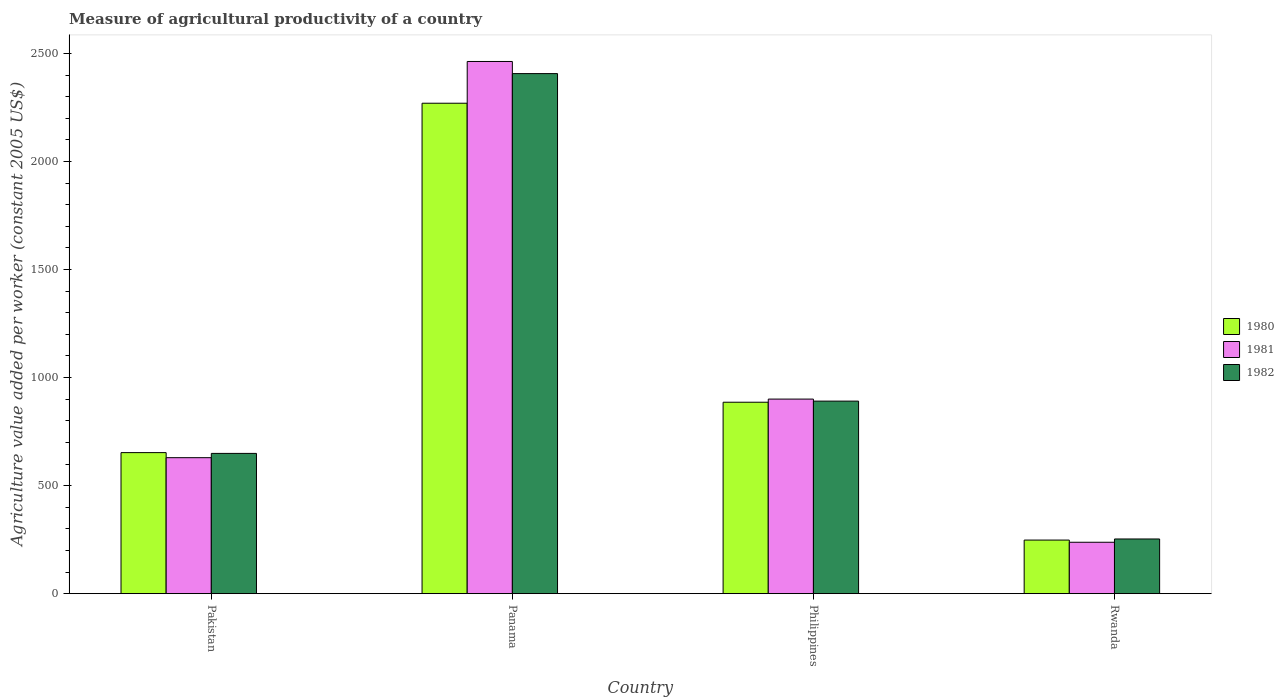How many bars are there on the 2nd tick from the left?
Provide a succinct answer. 3. What is the label of the 4th group of bars from the left?
Give a very brief answer. Rwanda. What is the measure of agricultural productivity in 1980 in Philippines?
Your response must be concise. 885.98. Across all countries, what is the maximum measure of agricultural productivity in 1982?
Provide a succinct answer. 2406.98. Across all countries, what is the minimum measure of agricultural productivity in 1981?
Your answer should be compact. 237.92. In which country was the measure of agricultural productivity in 1981 maximum?
Give a very brief answer. Panama. In which country was the measure of agricultural productivity in 1980 minimum?
Give a very brief answer. Rwanda. What is the total measure of agricultural productivity in 1981 in the graph?
Ensure brevity in your answer.  4230.88. What is the difference between the measure of agricultural productivity in 1980 in Panama and that in Philippines?
Offer a very short reply. 1383.91. What is the difference between the measure of agricultural productivity in 1981 in Panama and the measure of agricultural productivity in 1982 in Pakistan?
Your response must be concise. 1813.88. What is the average measure of agricultural productivity in 1981 per country?
Provide a short and direct response. 1057.72. What is the difference between the measure of agricultural productivity of/in 1980 and measure of agricultural productivity of/in 1982 in Pakistan?
Your answer should be compact. 3.62. What is the ratio of the measure of agricultural productivity in 1980 in Philippines to that in Rwanda?
Offer a very short reply. 3.57. What is the difference between the highest and the second highest measure of agricultural productivity in 1982?
Your answer should be very brief. -241.93. What is the difference between the highest and the lowest measure of agricultural productivity in 1980?
Keep it short and to the point. 2021.89. In how many countries, is the measure of agricultural productivity in 1980 greater than the average measure of agricultural productivity in 1980 taken over all countries?
Keep it short and to the point. 1. Is the sum of the measure of agricultural productivity in 1980 in Pakistan and Philippines greater than the maximum measure of agricultural productivity in 1981 across all countries?
Provide a succinct answer. No. How many bars are there?
Offer a very short reply. 12. Are all the bars in the graph horizontal?
Offer a terse response. No. Are the values on the major ticks of Y-axis written in scientific E-notation?
Your answer should be compact. No. Does the graph contain any zero values?
Offer a very short reply. No. How are the legend labels stacked?
Your response must be concise. Vertical. What is the title of the graph?
Ensure brevity in your answer.  Measure of agricultural productivity of a country. Does "1975" appear as one of the legend labels in the graph?
Your response must be concise. No. What is the label or title of the Y-axis?
Make the answer very short. Agriculture value added per worker (constant 2005 US$). What is the Agriculture value added per worker (constant 2005 US$) of 1980 in Pakistan?
Offer a terse response. 652.79. What is the Agriculture value added per worker (constant 2005 US$) in 1981 in Pakistan?
Ensure brevity in your answer.  629.36. What is the Agriculture value added per worker (constant 2005 US$) in 1982 in Pakistan?
Ensure brevity in your answer.  649.18. What is the Agriculture value added per worker (constant 2005 US$) of 1980 in Panama?
Keep it short and to the point. 2269.89. What is the Agriculture value added per worker (constant 2005 US$) of 1981 in Panama?
Your answer should be very brief. 2463.06. What is the Agriculture value added per worker (constant 2005 US$) of 1982 in Panama?
Keep it short and to the point. 2406.98. What is the Agriculture value added per worker (constant 2005 US$) of 1980 in Philippines?
Your answer should be very brief. 885.98. What is the Agriculture value added per worker (constant 2005 US$) of 1981 in Philippines?
Ensure brevity in your answer.  900.55. What is the Agriculture value added per worker (constant 2005 US$) in 1982 in Philippines?
Your answer should be compact. 891.1. What is the Agriculture value added per worker (constant 2005 US$) in 1980 in Rwanda?
Provide a succinct answer. 248.01. What is the Agriculture value added per worker (constant 2005 US$) of 1981 in Rwanda?
Your answer should be very brief. 237.92. What is the Agriculture value added per worker (constant 2005 US$) in 1982 in Rwanda?
Ensure brevity in your answer.  253.09. Across all countries, what is the maximum Agriculture value added per worker (constant 2005 US$) in 1980?
Ensure brevity in your answer.  2269.89. Across all countries, what is the maximum Agriculture value added per worker (constant 2005 US$) in 1981?
Make the answer very short. 2463.06. Across all countries, what is the maximum Agriculture value added per worker (constant 2005 US$) of 1982?
Offer a very short reply. 2406.98. Across all countries, what is the minimum Agriculture value added per worker (constant 2005 US$) in 1980?
Offer a very short reply. 248.01. Across all countries, what is the minimum Agriculture value added per worker (constant 2005 US$) of 1981?
Keep it short and to the point. 237.92. Across all countries, what is the minimum Agriculture value added per worker (constant 2005 US$) of 1982?
Your response must be concise. 253.09. What is the total Agriculture value added per worker (constant 2005 US$) of 1980 in the graph?
Give a very brief answer. 4056.67. What is the total Agriculture value added per worker (constant 2005 US$) of 1981 in the graph?
Your response must be concise. 4230.88. What is the total Agriculture value added per worker (constant 2005 US$) in 1982 in the graph?
Your response must be concise. 4200.35. What is the difference between the Agriculture value added per worker (constant 2005 US$) of 1980 in Pakistan and that in Panama?
Make the answer very short. -1617.1. What is the difference between the Agriculture value added per worker (constant 2005 US$) of 1981 in Pakistan and that in Panama?
Offer a terse response. -1833.7. What is the difference between the Agriculture value added per worker (constant 2005 US$) in 1982 in Pakistan and that in Panama?
Make the answer very short. -1757.8. What is the difference between the Agriculture value added per worker (constant 2005 US$) in 1980 in Pakistan and that in Philippines?
Offer a terse response. -233.19. What is the difference between the Agriculture value added per worker (constant 2005 US$) of 1981 in Pakistan and that in Philippines?
Provide a short and direct response. -271.19. What is the difference between the Agriculture value added per worker (constant 2005 US$) of 1982 in Pakistan and that in Philippines?
Your answer should be compact. -241.93. What is the difference between the Agriculture value added per worker (constant 2005 US$) of 1980 in Pakistan and that in Rwanda?
Offer a very short reply. 404.79. What is the difference between the Agriculture value added per worker (constant 2005 US$) of 1981 in Pakistan and that in Rwanda?
Your answer should be very brief. 391.44. What is the difference between the Agriculture value added per worker (constant 2005 US$) of 1982 in Pakistan and that in Rwanda?
Provide a succinct answer. 396.09. What is the difference between the Agriculture value added per worker (constant 2005 US$) in 1980 in Panama and that in Philippines?
Provide a short and direct response. 1383.91. What is the difference between the Agriculture value added per worker (constant 2005 US$) of 1981 in Panama and that in Philippines?
Ensure brevity in your answer.  1562.51. What is the difference between the Agriculture value added per worker (constant 2005 US$) in 1982 in Panama and that in Philippines?
Your response must be concise. 1515.88. What is the difference between the Agriculture value added per worker (constant 2005 US$) of 1980 in Panama and that in Rwanda?
Provide a succinct answer. 2021.89. What is the difference between the Agriculture value added per worker (constant 2005 US$) in 1981 in Panama and that in Rwanda?
Offer a very short reply. 2225.14. What is the difference between the Agriculture value added per worker (constant 2005 US$) of 1982 in Panama and that in Rwanda?
Provide a short and direct response. 2153.89. What is the difference between the Agriculture value added per worker (constant 2005 US$) of 1980 in Philippines and that in Rwanda?
Give a very brief answer. 637.98. What is the difference between the Agriculture value added per worker (constant 2005 US$) in 1981 in Philippines and that in Rwanda?
Make the answer very short. 662.63. What is the difference between the Agriculture value added per worker (constant 2005 US$) in 1982 in Philippines and that in Rwanda?
Provide a short and direct response. 638.01. What is the difference between the Agriculture value added per worker (constant 2005 US$) in 1980 in Pakistan and the Agriculture value added per worker (constant 2005 US$) in 1981 in Panama?
Give a very brief answer. -1810.26. What is the difference between the Agriculture value added per worker (constant 2005 US$) of 1980 in Pakistan and the Agriculture value added per worker (constant 2005 US$) of 1982 in Panama?
Offer a very short reply. -1754.19. What is the difference between the Agriculture value added per worker (constant 2005 US$) in 1981 in Pakistan and the Agriculture value added per worker (constant 2005 US$) in 1982 in Panama?
Ensure brevity in your answer.  -1777.62. What is the difference between the Agriculture value added per worker (constant 2005 US$) in 1980 in Pakistan and the Agriculture value added per worker (constant 2005 US$) in 1981 in Philippines?
Keep it short and to the point. -247.75. What is the difference between the Agriculture value added per worker (constant 2005 US$) of 1980 in Pakistan and the Agriculture value added per worker (constant 2005 US$) of 1982 in Philippines?
Your response must be concise. -238.31. What is the difference between the Agriculture value added per worker (constant 2005 US$) in 1981 in Pakistan and the Agriculture value added per worker (constant 2005 US$) in 1982 in Philippines?
Offer a terse response. -261.75. What is the difference between the Agriculture value added per worker (constant 2005 US$) of 1980 in Pakistan and the Agriculture value added per worker (constant 2005 US$) of 1981 in Rwanda?
Offer a very short reply. 414.88. What is the difference between the Agriculture value added per worker (constant 2005 US$) of 1980 in Pakistan and the Agriculture value added per worker (constant 2005 US$) of 1982 in Rwanda?
Provide a succinct answer. 399.7. What is the difference between the Agriculture value added per worker (constant 2005 US$) in 1981 in Pakistan and the Agriculture value added per worker (constant 2005 US$) in 1982 in Rwanda?
Make the answer very short. 376.27. What is the difference between the Agriculture value added per worker (constant 2005 US$) of 1980 in Panama and the Agriculture value added per worker (constant 2005 US$) of 1981 in Philippines?
Make the answer very short. 1369.34. What is the difference between the Agriculture value added per worker (constant 2005 US$) in 1980 in Panama and the Agriculture value added per worker (constant 2005 US$) in 1982 in Philippines?
Your response must be concise. 1378.79. What is the difference between the Agriculture value added per worker (constant 2005 US$) of 1981 in Panama and the Agriculture value added per worker (constant 2005 US$) of 1982 in Philippines?
Ensure brevity in your answer.  1571.95. What is the difference between the Agriculture value added per worker (constant 2005 US$) of 1980 in Panama and the Agriculture value added per worker (constant 2005 US$) of 1981 in Rwanda?
Your answer should be very brief. 2031.97. What is the difference between the Agriculture value added per worker (constant 2005 US$) in 1980 in Panama and the Agriculture value added per worker (constant 2005 US$) in 1982 in Rwanda?
Offer a very short reply. 2016.8. What is the difference between the Agriculture value added per worker (constant 2005 US$) of 1981 in Panama and the Agriculture value added per worker (constant 2005 US$) of 1982 in Rwanda?
Your answer should be very brief. 2209.97. What is the difference between the Agriculture value added per worker (constant 2005 US$) in 1980 in Philippines and the Agriculture value added per worker (constant 2005 US$) in 1981 in Rwanda?
Your answer should be very brief. 648.06. What is the difference between the Agriculture value added per worker (constant 2005 US$) of 1980 in Philippines and the Agriculture value added per worker (constant 2005 US$) of 1982 in Rwanda?
Give a very brief answer. 632.89. What is the difference between the Agriculture value added per worker (constant 2005 US$) in 1981 in Philippines and the Agriculture value added per worker (constant 2005 US$) in 1982 in Rwanda?
Offer a terse response. 647.46. What is the average Agriculture value added per worker (constant 2005 US$) in 1980 per country?
Make the answer very short. 1014.17. What is the average Agriculture value added per worker (constant 2005 US$) of 1981 per country?
Offer a very short reply. 1057.72. What is the average Agriculture value added per worker (constant 2005 US$) of 1982 per country?
Your response must be concise. 1050.09. What is the difference between the Agriculture value added per worker (constant 2005 US$) in 1980 and Agriculture value added per worker (constant 2005 US$) in 1981 in Pakistan?
Your response must be concise. 23.44. What is the difference between the Agriculture value added per worker (constant 2005 US$) in 1980 and Agriculture value added per worker (constant 2005 US$) in 1982 in Pakistan?
Keep it short and to the point. 3.62. What is the difference between the Agriculture value added per worker (constant 2005 US$) in 1981 and Agriculture value added per worker (constant 2005 US$) in 1982 in Pakistan?
Keep it short and to the point. -19.82. What is the difference between the Agriculture value added per worker (constant 2005 US$) of 1980 and Agriculture value added per worker (constant 2005 US$) of 1981 in Panama?
Make the answer very short. -193.17. What is the difference between the Agriculture value added per worker (constant 2005 US$) in 1980 and Agriculture value added per worker (constant 2005 US$) in 1982 in Panama?
Ensure brevity in your answer.  -137.09. What is the difference between the Agriculture value added per worker (constant 2005 US$) in 1981 and Agriculture value added per worker (constant 2005 US$) in 1982 in Panama?
Provide a succinct answer. 56.08. What is the difference between the Agriculture value added per worker (constant 2005 US$) in 1980 and Agriculture value added per worker (constant 2005 US$) in 1981 in Philippines?
Offer a very short reply. -14.56. What is the difference between the Agriculture value added per worker (constant 2005 US$) in 1980 and Agriculture value added per worker (constant 2005 US$) in 1982 in Philippines?
Keep it short and to the point. -5.12. What is the difference between the Agriculture value added per worker (constant 2005 US$) in 1981 and Agriculture value added per worker (constant 2005 US$) in 1982 in Philippines?
Make the answer very short. 9.44. What is the difference between the Agriculture value added per worker (constant 2005 US$) of 1980 and Agriculture value added per worker (constant 2005 US$) of 1981 in Rwanda?
Your response must be concise. 10.09. What is the difference between the Agriculture value added per worker (constant 2005 US$) of 1980 and Agriculture value added per worker (constant 2005 US$) of 1982 in Rwanda?
Give a very brief answer. -5.08. What is the difference between the Agriculture value added per worker (constant 2005 US$) of 1981 and Agriculture value added per worker (constant 2005 US$) of 1982 in Rwanda?
Make the answer very short. -15.17. What is the ratio of the Agriculture value added per worker (constant 2005 US$) of 1980 in Pakistan to that in Panama?
Keep it short and to the point. 0.29. What is the ratio of the Agriculture value added per worker (constant 2005 US$) of 1981 in Pakistan to that in Panama?
Offer a terse response. 0.26. What is the ratio of the Agriculture value added per worker (constant 2005 US$) in 1982 in Pakistan to that in Panama?
Offer a very short reply. 0.27. What is the ratio of the Agriculture value added per worker (constant 2005 US$) of 1980 in Pakistan to that in Philippines?
Offer a terse response. 0.74. What is the ratio of the Agriculture value added per worker (constant 2005 US$) in 1981 in Pakistan to that in Philippines?
Your answer should be compact. 0.7. What is the ratio of the Agriculture value added per worker (constant 2005 US$) in 1982 in Pakistan to that in Philippines?
Offer a terse response. 0.73. What is the ratio of the Agriculture value added per worker (constant 2005 US$) of 1980 in Pakistan to that in Rwanda?
Offer a very short reply. 2.63. What is the ratio of the Agriculture value added per worker (constant 2005 US$) of 1981 in Pakistan to that in Rwanda?
Provide a short and direct response. 2.65. What is the ratio of the Agriculture value added per worker (constant 2005 US$) of 1982 in Pakistan to that in Rwanda?
Give a very brief answer. 2.56. What is the ratio of the Agriculture value added per worker (constant 2005 US$) of 1980 in Panama to that in Philippines?
Your answer should be compact. 2.56. What is the ratio of the Agriculture value added per worker (constant 2005 US$) in 1981 in Panama to that in Philippines?
Offer a terse response. 2.74. What is the ratio of the Agriculture value added per worker (constant 2005 US$) in 1982 in Panama to that in Philippines?
Keep it short and to the point. 2.7. What is the ratio of the Agriculture value added per worker (constant 2005 US$) in 1980 in Panama to that in Rwanda?
Ensure brevity in your answer.  9.15. What is the ratio of the Agriculture value added per worker (constant 2005 US$) in 1981 in Panama to that in Rwanda?
Offer a very short reply. 10.35. What is the ratio of the Agriculture value added per worker (constant 2005 US$) in 1982 in Panama to that in Rwanda?
Your response must be concise. 9.51. What is the ratio of the Agriculture value added per worker (constant 2005 US$) of 1980 in Philippines to that in Rwanda?
Ensure brevity in your answer.  3.57. What is the ratio of the Agriculture value added per worker (constant 2005 US$) in 1981 in Philippines to that in Rwanda?
Make the answer very short. 3.79. What is the ratio of the Agriculture value added per worker (constant 2005 US$) of 1982 in Philippines to that in Rwanda?
Your response must be concise. 3.52. What is the difference between the highest and the second highest Agriculture value added per worker (constant 2005 US$) in 1980?
Give a very brief answer. 1383.91. What is the difference between the highest and the second highest Agriculture value added per worker (constant 2005 US$) in 1981?
Offer a very short reply. 1562.51. What is the difference between the highest and the second highest Agriculture value added per worker (constant 2005 US$) of 1982?
Make the answer very short. 1515.88. What is the difference between the highest and the lowest Agriculture value added per worker (constant 2005 US$) of 1980?
Offer a terse response. 2021.89. What is the difference between the highest and the lowest Agriculture value added per worker (constant 2005 US$) of 1981?
Your answer should be compact. 2225.14. What is the difference between the highest and the lowest Agriculture value added per worker (constant 2005 US$) in 1982?
Provide a short and direct response. 2153.89. 